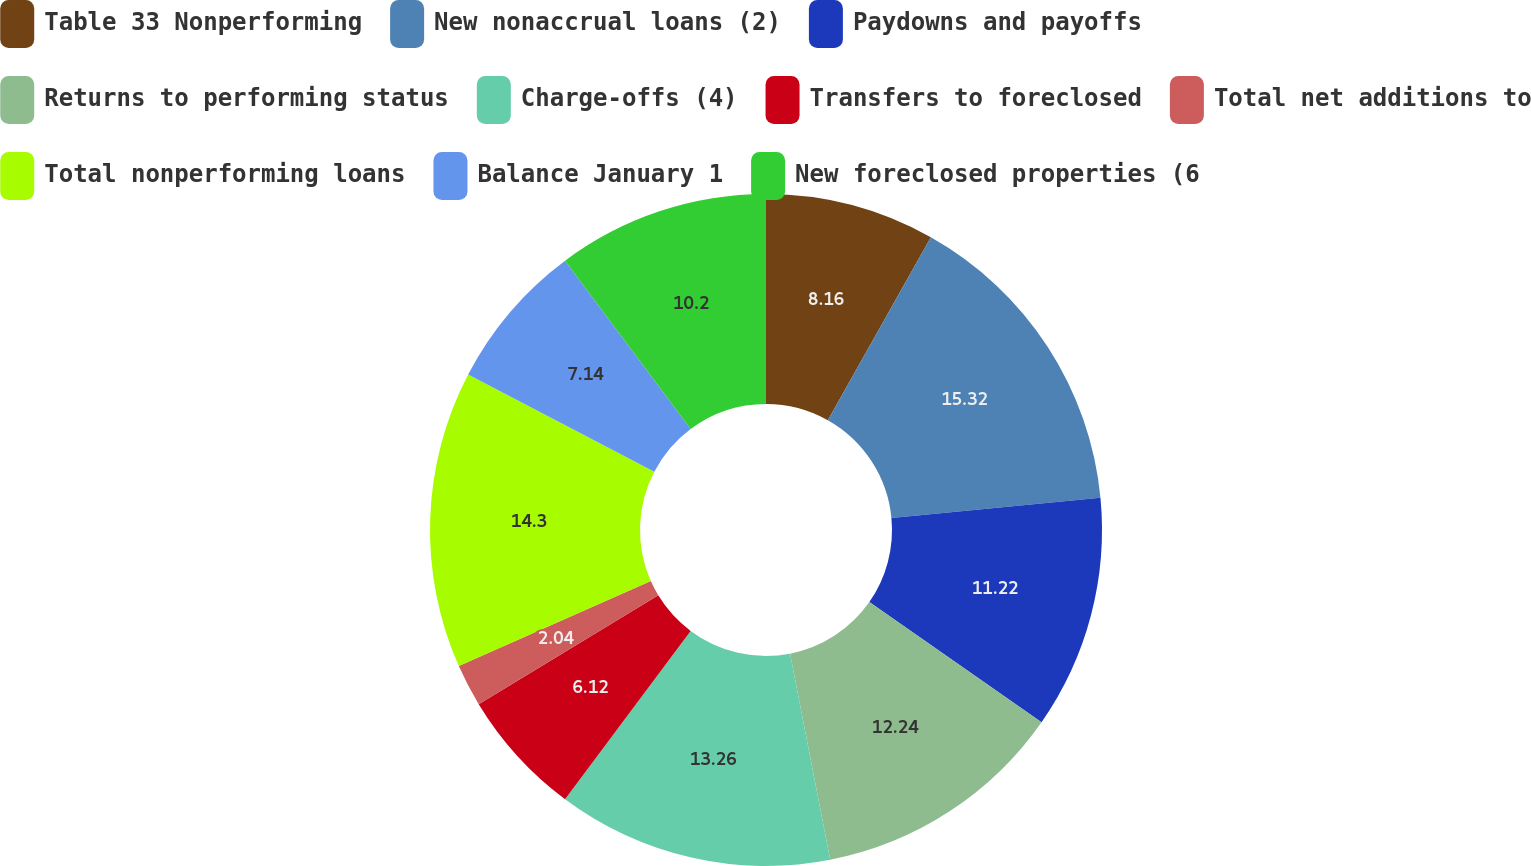Convert chart to OTSL. <chart><loc_0><loc_0><loc_500><loc_500><pie_chart><fcel>Table 33 Nonperforming<fcel>New nonaccrual loans (2)<fcel>Paydowns and payoffs<fcel>Returns to performing status<fcel>Charge-offs (4)<fcel>Transfers to foreclosed<fcel>Total net additions to<fcel>Total nonperforming loans<fcel>Balance January 1<fcel>New foreclosed properties (6<nl><fcel>8.16%<fcel>15.31%<fcel>11.22%<fcel>12.24%<fcel>13.26%<fcel>6.12%<fcel>2.04%<fcel>14.29%<fcel>7.14%<fcel>10.2%<nl></chart> 